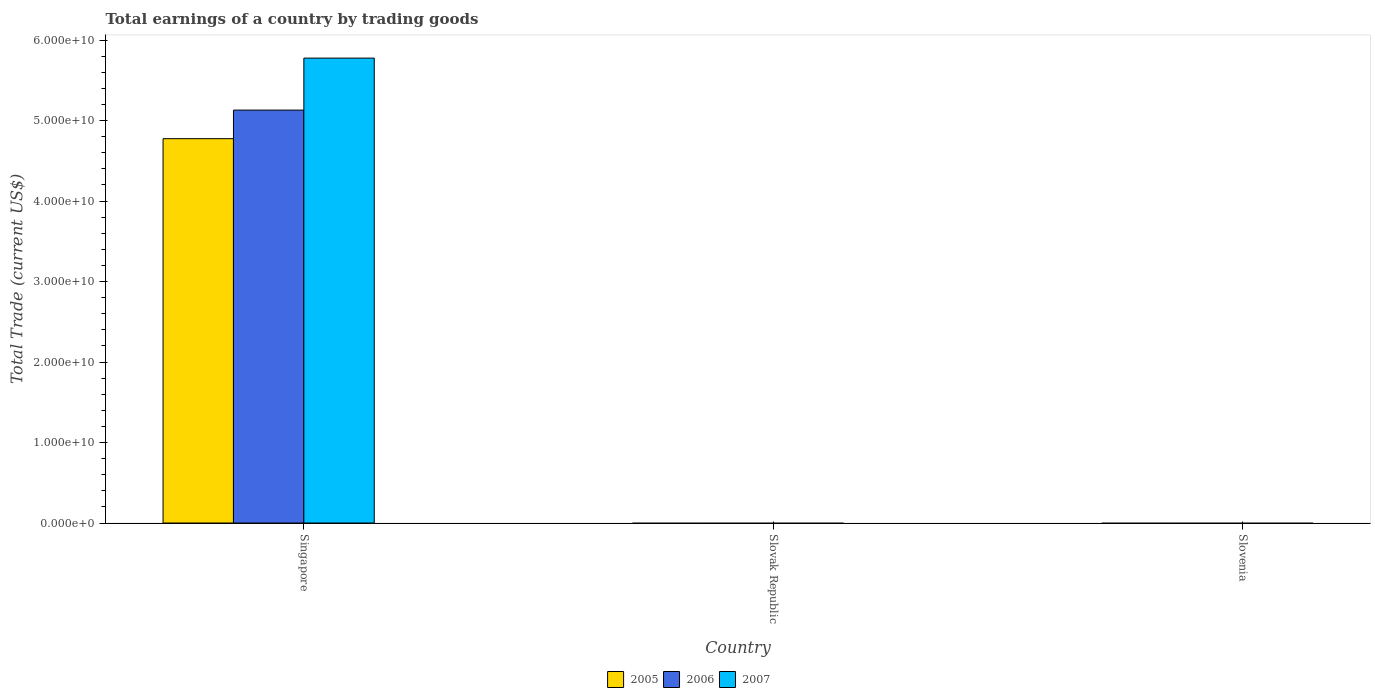Are the number of bars on each tick of the X-axis equal?
Your answer should be very brief. No. How many bars are there on the 3rd tick from the left?
Your answer should be compact. 0. What is the label of the 1st group of bars from the left?
Give a very brief answer. Singapore. Across all countries, what is the maximum total earnings in 2005?
Provide a short and direct response. 4.77e+1. In which country was the total earnings in 2006 maximum?
Keep it short and to the point. Singapore. What is the total total earnings in 2006 in the graph?
Give a very brief answer. 5.13e+1. What is the difference between the total earnings in 2006 in Slovenia and the total earnings in 2007 in Singapore?
Make the answer very short. -5.77e+1. What is the average total earnings in 2007 per country?
Keep it short and to the point. 1.92e+1. What is the difference between the total earnings of/in 2005 and total earnings of/in 2007 in Singapore?
Give a very brief answer. -1.00e+1. What is the difference between the highest and the lowest total earnings in 2006?
Give a very brief answer. 5.13e+1. In how many countries, is the total earnings in 2005 greater than the average total earnings in 2005 taken over all countries?
Provide a short and direct response. 1. Are all the bars in the graph horizontal?
Keep it short and to the point. No. What is the difference between two consecutive major ticks on the Y-axis?
Make the answer very short. 1.00e+1. Does the graph contain grids?
Offer a terse response. No. Where does the legend appear in the graph?
Your answer should be compact. Bottom center. What is the title of the graph?
Offer a very short reply. Total earnings of a country by trading goods. What is the label or title of the X-axis?
Provide a succinct answer. Country. What is the label or title of the Y-axis?
Your response must be concise. Total Trade (current US$). What is the Total Trade (current US$) in 2005 in Singapore?
Keep it short and to the point. 4.77e+1. What is the Total Trade (current US$) in 2006 in Singapore?
Your answer should be very brief. 5.13e+1. What is the Total Trade (current US$) in 2007 in Singapore?
Give a very brief answer. 5.77e+1. What is the Total Trade (current US$) of 2005 in Slovak Republic?
Provide a succinct answer. 0. What is the Total Trade (current US$) in 2006 in Slovak Republic?
Offer a very short reply. 0. Across all countries, what is the maximum Total Trade (current US$) in 2005?
Ensure brevity in your answer.  4.77e+1. Across all countries, what is the maximum Total Trade (current US$) in 2006?
Offer a terse response. 5.13e+1. Across all countries, what is the maximum Total Trade (current US$) in 2007?
Your answer should be compact. 5.77e+1. Across all countries, what is the minimum Total Trade (current US$) in 2007?
Your answer should be very brief. 0. What is the total Total Trade (current US$) of 2005 in the graph?
Your answer should be very brief. 4.77e+1. What is the total Total Trade (current US$) in 2006 in the graph?
Your answer should be compact. 5.13e+1. What is the total Total Trade (current US$) in 2007 in the graph?
Ensure brevity in your answer.  5.77e+1. What is the average Total Trade (current US$) in 2005 per country?
Ensure brevity in your answer.  1.59e+1. What is the average Total Trade (current US$) of 2006 per country?
Your answer should be very brief. 1.71e+1. What is the average Total Trade (current US$) in 2007 per country?
Provide a short and direct response. 1.92e+1. What is the difference between the Total Trade (current US$) in 2005 and Total Trade (current US$) in 2006 in Singapore?
Your response must be concise. -3.55e+09. What is the difference between the Total Trade (current US$) of 2005 and Total Trade (current US$) of 2007 in Singapore?
Your answer should be very brief. -1.00e+1. What is the difference between the Total Trade (current US$) of 2006 and Total Trade (current US$) of 2007 in Singapore?
Your response must be concise. -6.46e+09. What is the difference between the highest and the lowest Total Trade (current US$) in 2005?
Your answer should be very brief. 4.77e+1. What is the difference between the highest and the lowest Total Trade (current US$) in 2006?
Your response must be concise. 5.13e+1. What is the difference between the highest and the lowest Total Trade (current US$) of 2007?
Provide a succinct answer. 5.77e+1. 